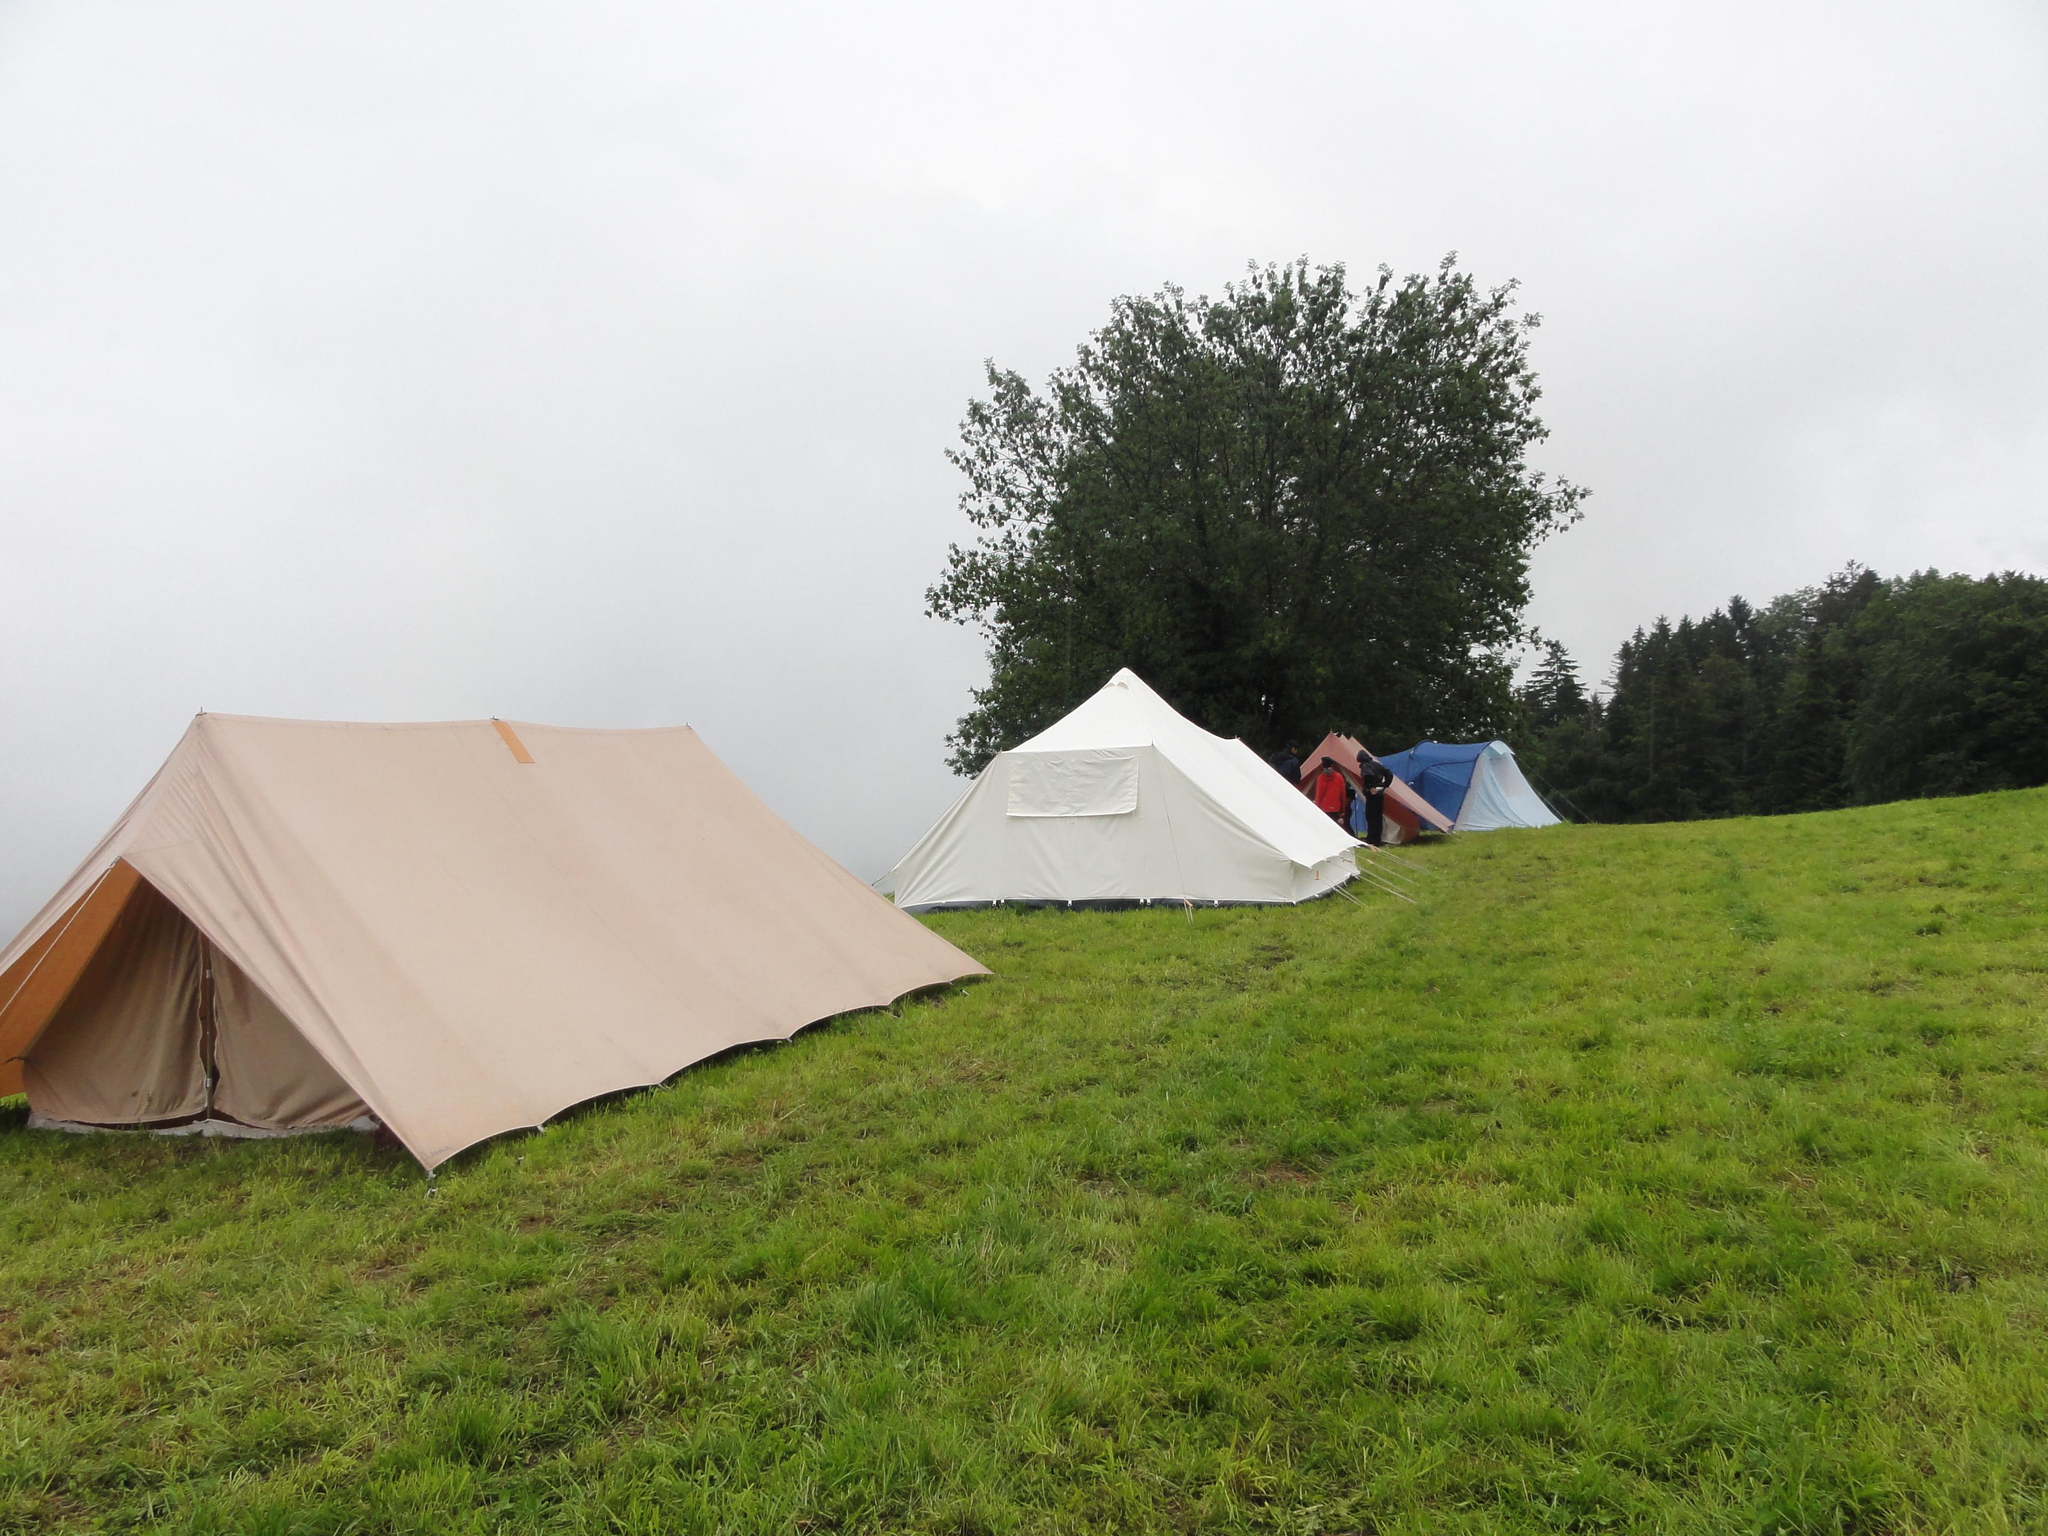What type of temporary shelters can be seen in the image? There are tents in the image. What are the people on the ground doing? The facts do not specify what the people on the ground are doing. What can be seen in the background of the image? There are trees and the sky visible in the background of the image. Where is the store located in the image? There is no store present in the image. What type of berry can be seen growing on the trees in the image? There is no mention of berries or any specific type of vegetation on the trees in the image. 